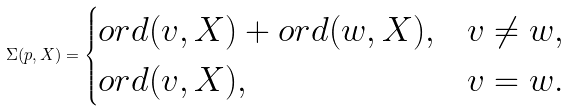<formula> <loc_0><loc_0><loc_500><loc_500>\Sigma ( p , X ) = \begin{cases} { o r d } ( v , X ) + { o r d } ( w , X ) , & v \neq w , \\ { o r d } ( v , X ) , & v = w . \end{cases}</formula> 